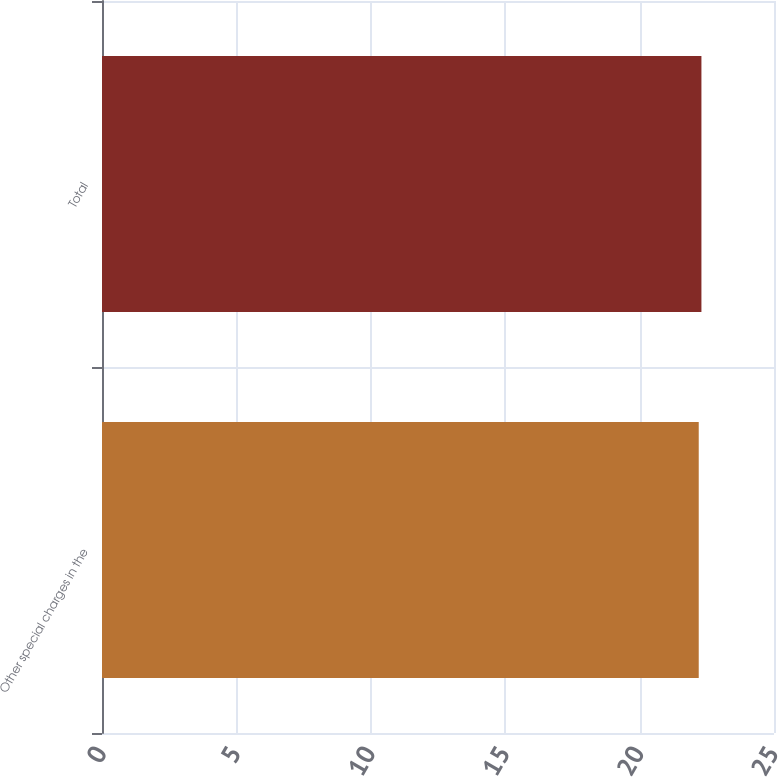Convert chart. <chart><loc_0><loc_0><loc_500><loc_500><bar_chart><fcel>Other special charges in the<fcel>Total<nl><fcel>22.2<fcel>22.3<nl></chart> 